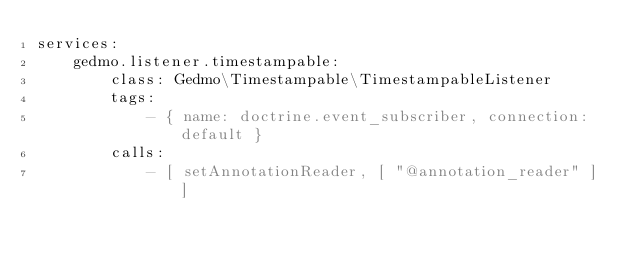Convert code to text. <code><loc_0><loc_0><loc_500><loc_500><_YAML_>services:
    gedmo.listener.timestampable:
        class: Gedmo\Timestampable\TimestampableListener
        tags:
            - { name: doctrine.event_subscriber, connection: default }
        calls:
            - [ setAnnotationReader, [ "@annotation_reader" ] ]
</code> 